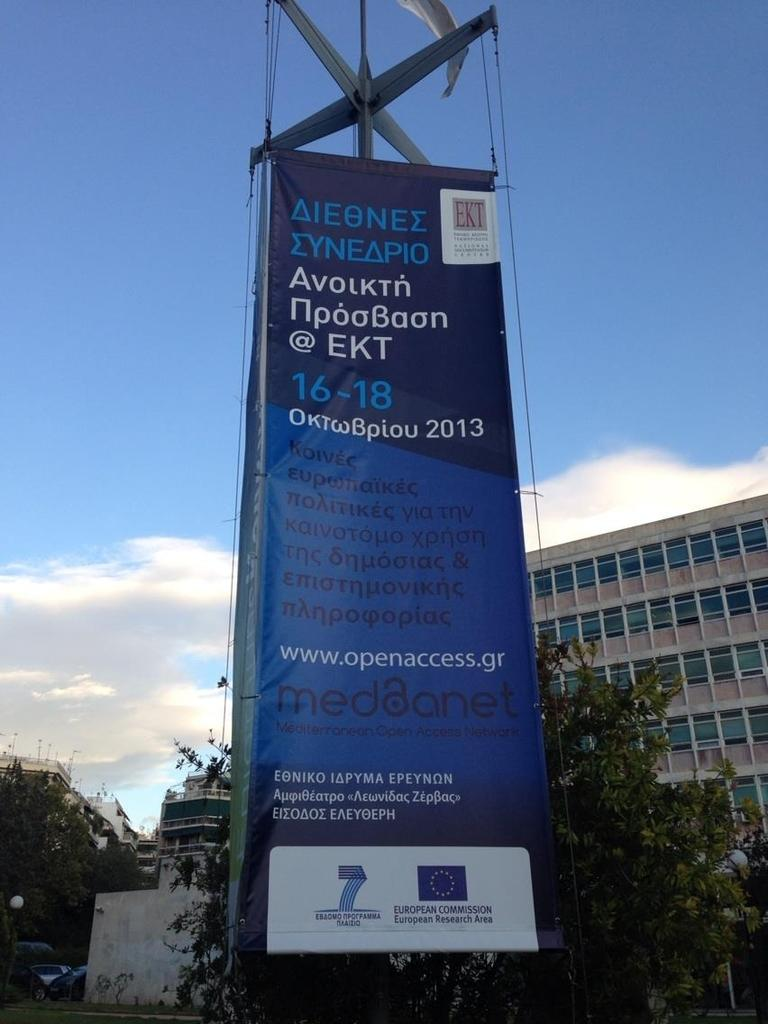<image>
Share a concise interpretation of the image provided. Blue sign for www.openaccess.gr in front of a tall building 